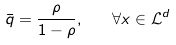<formula> <loc_0><loc_0><loc_500><loc_500>\bar { q } = \frac { \rho } { 1 - \rho } , \quad \forall x \in \mathcal { L } ^ { d }</formula> 